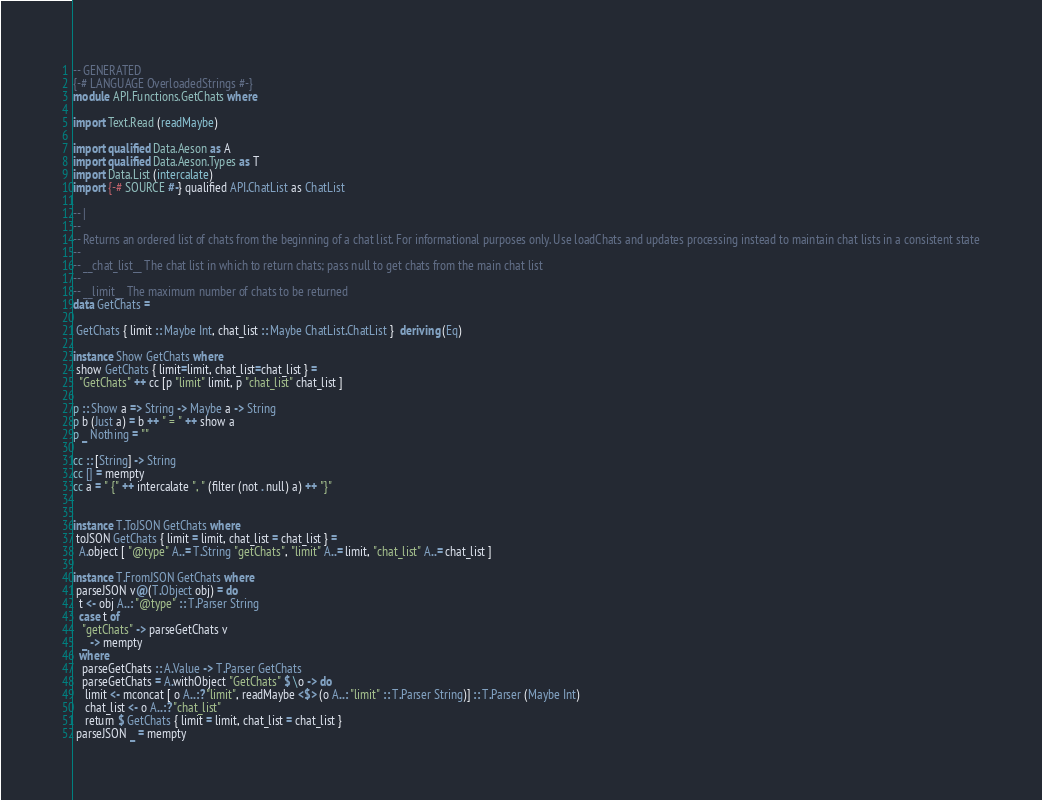Convert code to text. <code><loc_0><loc_0><loc_500><loc_500><_Haskell_>-- GENERATED
{-# LANGUAGE OverloadedStrings #-}
module API.Functions.GetChats where

import Text.Read (readMaybe)

import qualified Data.Aeson as A
import qualified Data.Aeson.Types as T
import Data.List (intercalate)
import {-# SOURCE #-} qualified API.ChatList as ChatList

-- |
-- 
-- Returns an ordered list of chats from the beginning of a chat list. For informational purposes only. Use loadChats and updates processing instead to maintain chat lists in a consistent state
-- 
-- __chat_list__ The chat list in which to return chats; pass null to get chats from the main chat list
-- 
-- __limit__ The maximum number of chats to be returned
data GetChats = 

 GetChats { limit :: Maybe Int, chat_list :: Maybe ChatList.ChatList }  deriving (Eq)

instance Show GetChats where
 show GetChats { limit=limit, chat_list=chat_list } =
  "GetChats" ++ cc [p "limit" limit, p "chat_list" chat_list ]

p :: Show a => String -> Maybe a -> String
p b (Just a) = b ++ " = " ++ show a
p _ Nothing = ""

cc :: [String] -> String
cc [] = mempty
cc a = " {" ++ intercalate ", " (filter (not . null) a) ++ "}"


instance T.ToJSON GetChats where
 toJSON GetChats { limit = limit, chat_list = chat_list } =
  A.object [ "@type" A..= T.String "getChats", "limit" A..= limit, "chat_list" A..= chat_list ]

instance T.FromJSON GetChats where
 parseJSON v@(T.Object obj) = do
  t <- obj A..: "@type" :: T.Parser String
  case t of
   "getChats" -> parseGetChats v
   _ -> mempty
  where
   parseGetChats :: A.Value -> T.Parser GetChats
   parseGetChats = A.withObject "GetChats" $ \o -> do
    limit <- mconcat [ o A..:? "limit", readMaybe <$> (o A..: "limit" :: T.Parser String)] :: T.Parser (Maybe Int)
    chat_list <- o A..:? "chat_list"
    return $ GetChats { limit = limit, chat_list = chat_list }
 parseJSON _ = mempty
</code> 